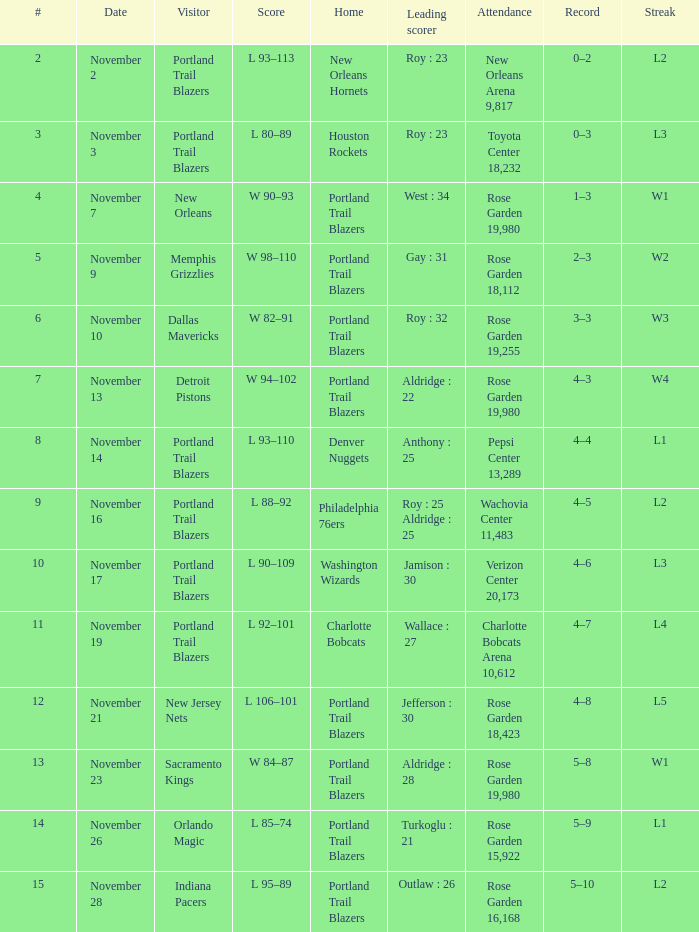 who is the leading scorer where home is charlotte bobcats Wallace : 27. 